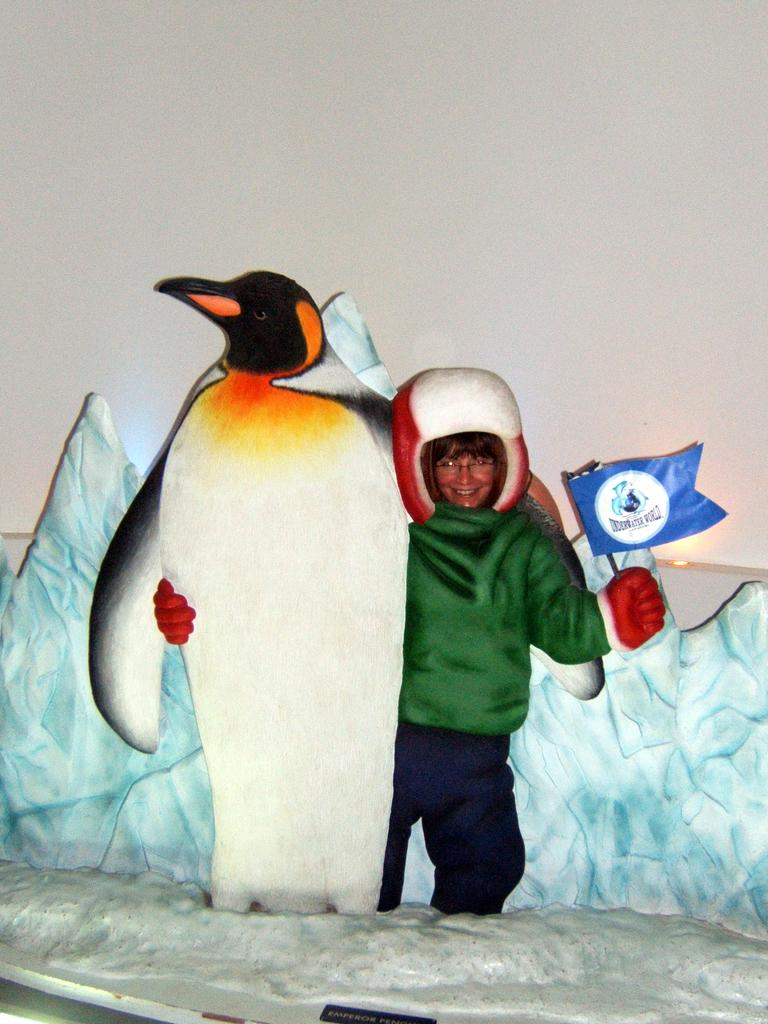Who or what is present in the image? There is a person and a penguin in the image. How are the person and the penguin related in the image? The person is interacting with the penguin. Can you describe the interaction between the person and the penguin? Unfortunately, the specific interaction cannot be determined from the provided facts. What rule does the dog follow in the image? There is no dog present in the image, so no rules can be attributed to a dog. 